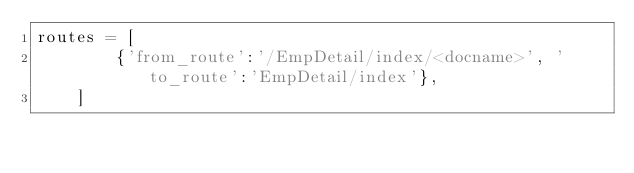Convert code to text. <code><loc_0><loc_0><loc_500><loc_500><_Python_>routes = [
	    {'from_route':'/EmpDetail/index/<docname>', 'to_route':'EmpDetail/index'},
    ]</code> 